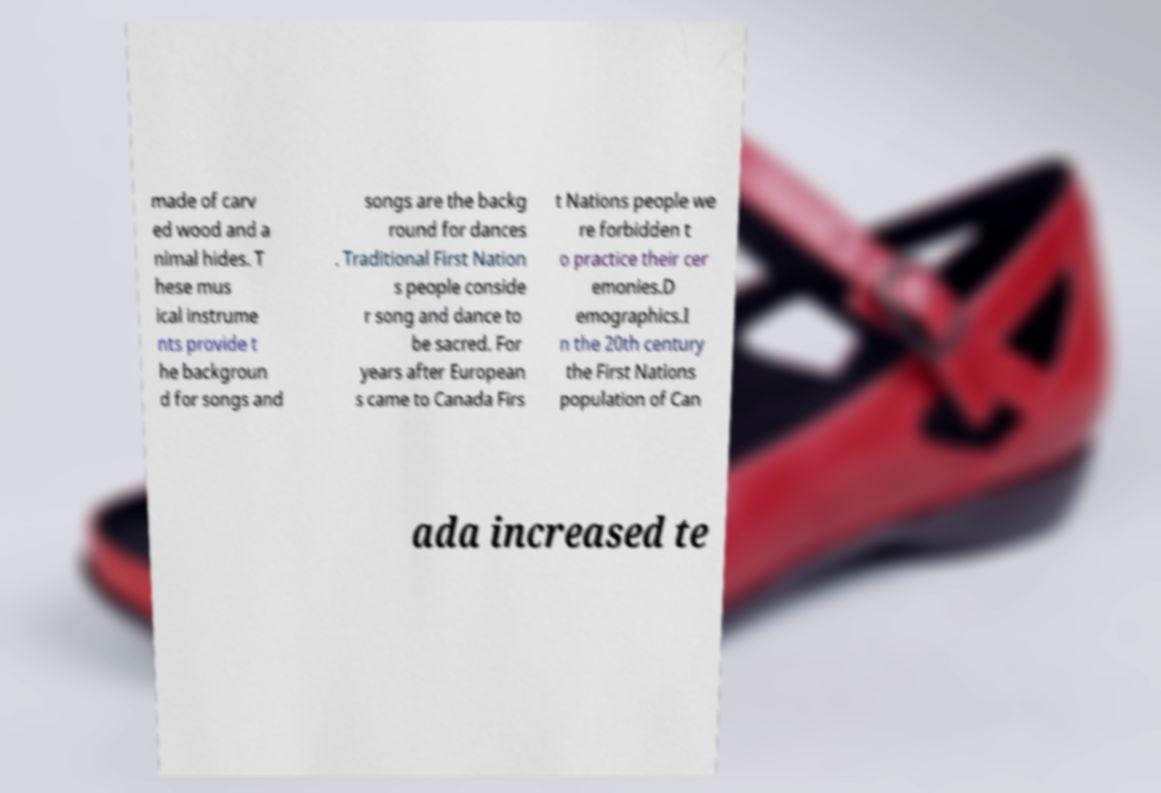Can you accurately transcribe the text from the provided image for me? made of carv ed wood and a nimal hides. T hese mus ical instrume nts provide t he backgroun d for songs and songs are the backg round for dances . Traditional First Nation s people conside r song and dance to be sacred. For years after European s came to Canada Firs t Nations people we re forbidden t o practice their cer emonies.D emographics.I n the 20th century the First Nations population of Can ada increased te 